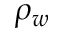<formula> <loc_0><loc_0><loc_500><loc_500>\rho _ { w }</formula> 